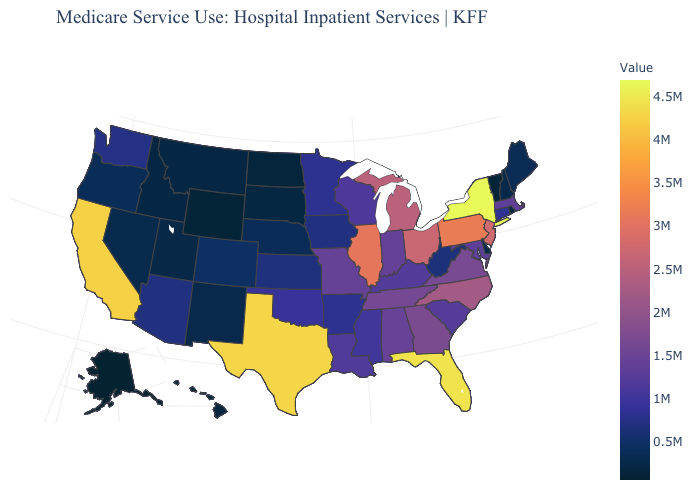Which states have the lowest value in the MidWest?
Be succinct. North Dakota. Does the map have missing data?
Quick response, please. No. Does Tennessee have a higher value than Arizona?
Short answer required. Yes. Does New York have the highest value in the USA?
Write a very short answer. Yes. 